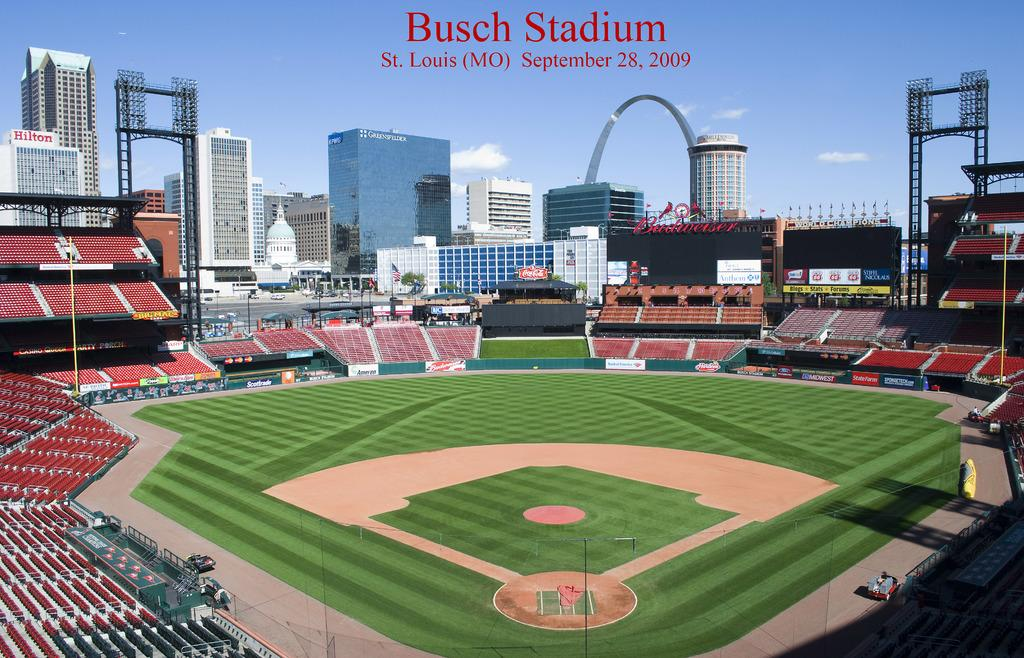<image>
Give a short and clear explanation of the subsequent image. The stands are completely empty and it is a beautiful clear day in the image on a postcard for Bush Stadium on September 28, 2009. 